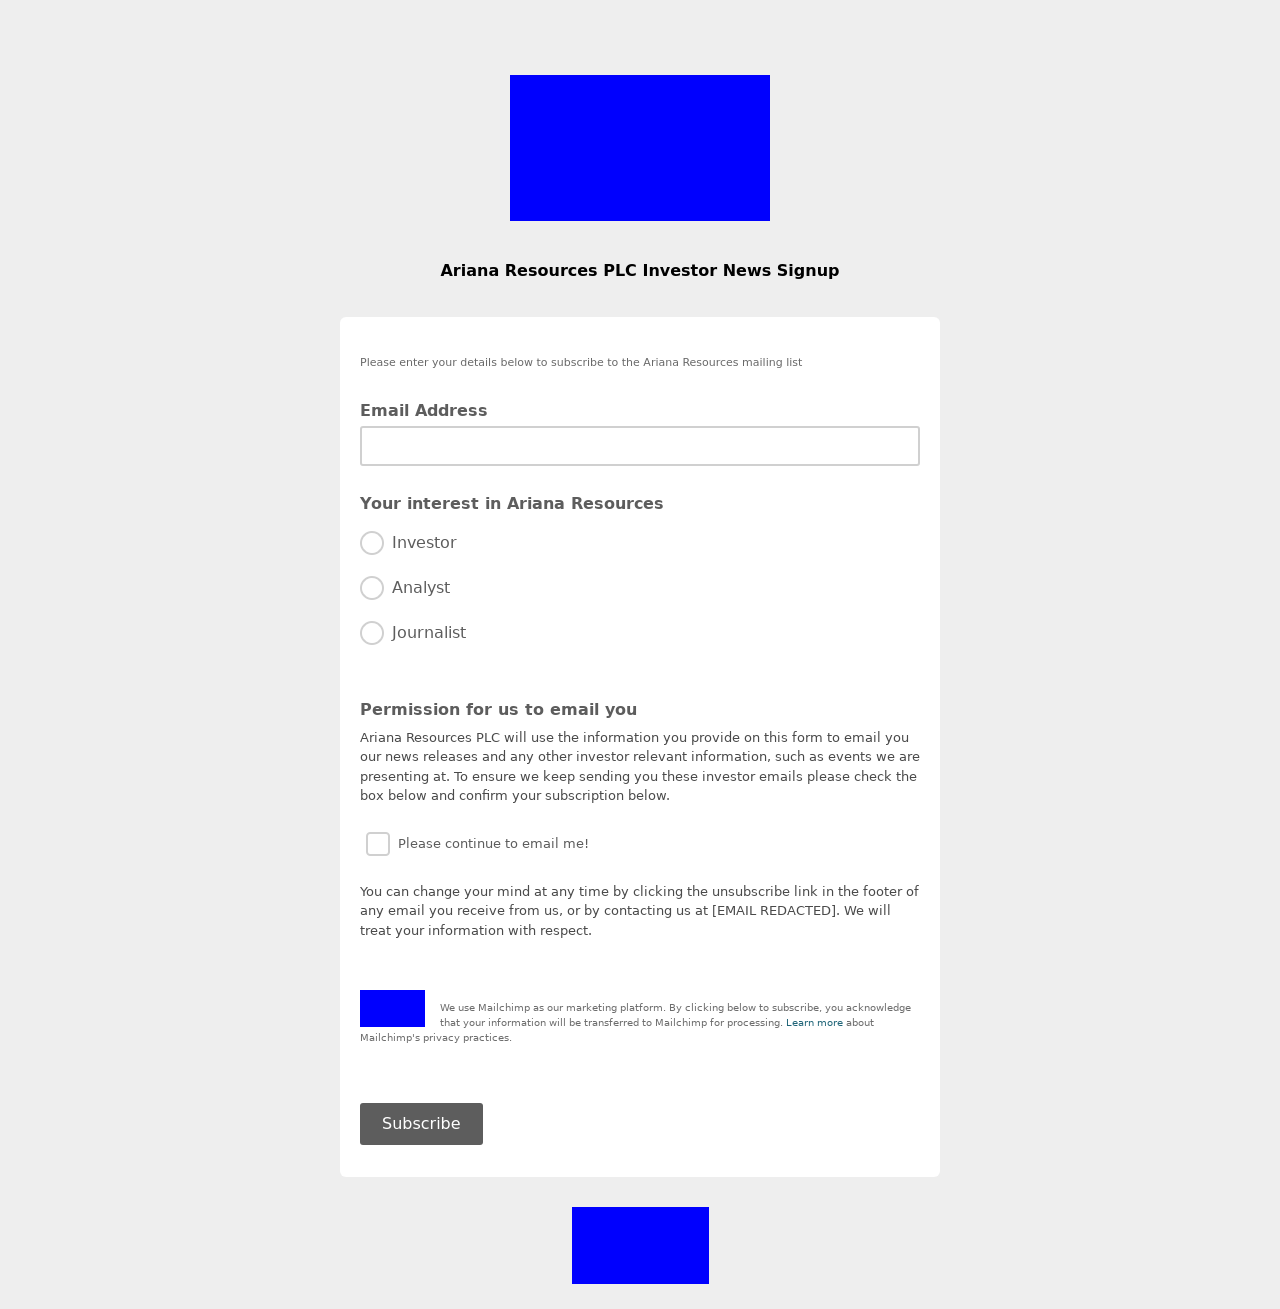Could you explain how privacy is managed on this platform based on the image? The image indicates the use of several measures to manage privacy:
1. **User Consent**: The form requires users to actively check a box, consenting to receive emails, which is essential for compliance with data protection regulations like GDPR.
2. **Information Security**: The disclaimer about using Mailchimp indicates that the user's data will be transferred for processing, and a link is provided to learn more about Mailchimp's privacy practices.
3. **Unsubscribe Option**: Users are informed they can unsubscribe at any time by clicking a link provided in the emails, which respects the user's right to withdraw consent. 